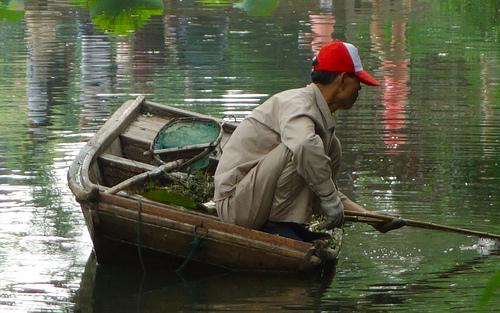Write a short sentence about the person in the image and their activity. A man is fishing with a net on a small wooden boat in calm water. Describe the clothing and accessories of the person in the image. The man is wearing a light-colored jacket, dark pants, and a red baseball cap. Provide a brief description of the scene involving the man and the boat. A fisherman sits in a wooden boat, handling a net, surrounded by calm water reflecting the surrounding greenery. Summarize the setting and atmosphere of the image in one sentence. The photo captures a serene scene of a fisherman in a boat with water reflecting light and surrounding greenery. Explain briefly the action taking place in the image with the fisherman and his equipment. A fisherman wearing a red baseball cap is using a net to fish from his wooden boat in calm waters. Describe the fisherman's attire and the items visible in his boat. The fisherman is dressed in a light jacket and dark pants with a red cap, and his boat contains a net and some greenery. Narrate the scene involving the fisherman, the boat, and the water. A man in a red baseball cap is fishing with a net from a small wooden boat, surrounded by calm water reflecting light and greenery. Mention the primary object and colors present in the image. The image features a man wearing a red baseball cap and dark pants, sitting in a brown boat with a net. In one sentence, mention what the fisherman is wearing and using in the image. The fisherman wears a red baseball cap and is using a net to fish from his wooden boat. Write a concise statement about the fisherman's appearance and actions. The fisherman, dressed in a light jacket and red baseball cap, is seen fishing with a net in a wooden boat. 